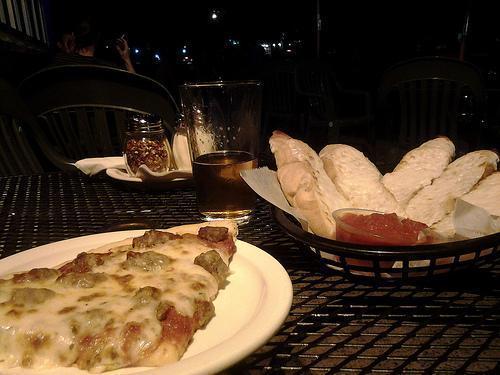How many slices of bread are there?
Give a very brief answer. 5. 